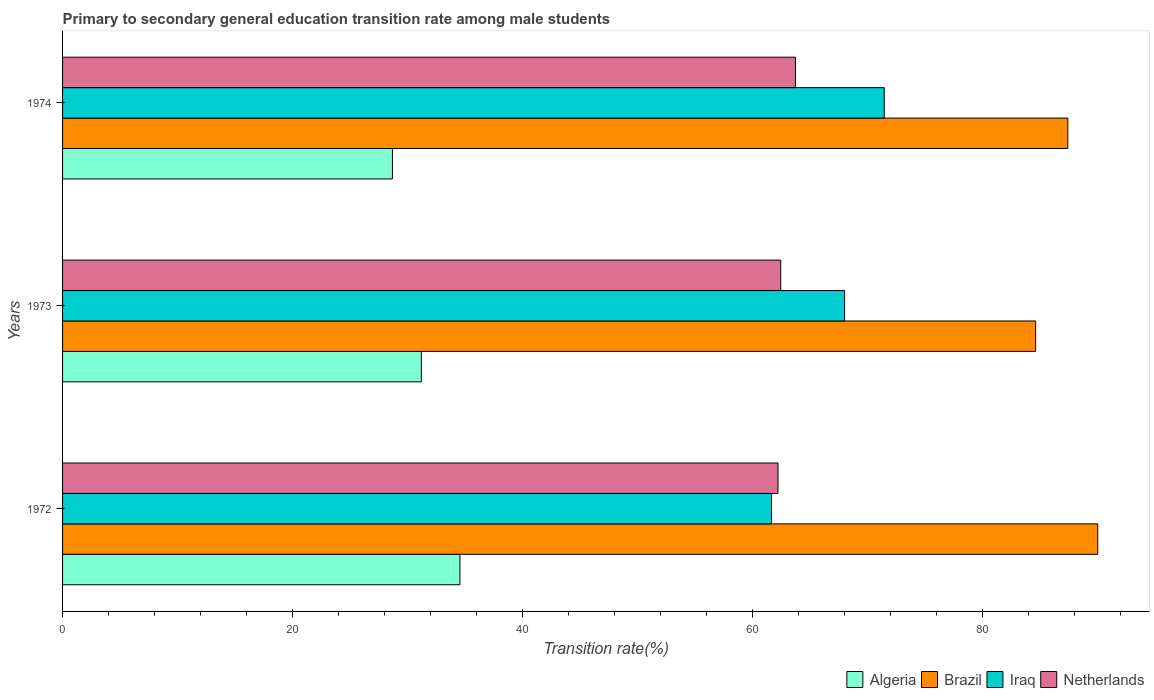How many different coloured bars are there?
Ensure brevity in your answer.  4. How many groups of bars are there?
Offer a very short reply. 3. Are the number of bars on each tick of the Y-axis equal?
Keep it short and to the point. Yes. How many bars are there on the 1st tick from the bottom?
Give a very brief answer. 4. What is the label of the 3rd group of bars from the top?
Give a very brief answer. 1972. What is the transition rate in Brazil in 1974?
Offer a terse response. 87.41. Across all years, what is the maximum transition rate in Netherlands?
Keep it short and to the point. 63.72. Across all years, what is the minimum transition rate in Algeria?
Keep it short and to the point. 28.68. What is the total transition rate in Netherlands in the graph?
Provide a short and direct response. 188.38. What is the difference between the transition rate in Iraq in 1973 and that in 1974?
Give a very brief answer. -3.45. What is the difference between the transition rate in Iraq in 1974 and the transition rate in Netherlands in 1972?
Provide a short and direct response. 9.24. What is the average transition rate in Iraq per year?
Your answer should be compact. 67.03. In the year 1973, what is the difference between the transition rate in Netherlands and transition rate in Algeria?
Provide a short and direct response. 31.26. What is the ratio of the transition rate in Iraq in 1972 to that in 1973?
Ensure brevity in your answer.  0.91. Is the transition rate in Algeria in 1972 less than that in 1974?
Your response must be concise. No. Is the difference between the transition rate in Netherlands in 1972 and 1974 greater than the difference between the transition rate in Algeria in 1972 and 1974?
Your answer should be compact. No. What is the difference between the highest and the second highest transition rate in Algeria?
Provide a short and direct response. 3.36. What is the difference between the highest and the lowest transition rate in Iraq?
Offer a very short reply. 9.8. In how many years, is the transition rate in Algeria greater than the average transition rate in Algeria taken over all years?
Offer a very short reply. 1. Is it the case that in every year, the sum of the transition rate in Brazil and transition rate in Algeria is greater than the sum of transition rate in Netherlands and transition rate in Iraq?
Your answer should be very brief. Yes. What does the 2nd bar from the top in 1974 represents?
Provide a succinct answer. Iraq. Is it the case that in every year, the sum of the transition rate in Algeria and transition rate in Iraq is greater than the transition rate in Brazil?
Keep it short and to the point. Yes. How many bars are there?
Offer a terse response. 12. How many years are there in the graph?
Offer a very short reply. 3. What is the difference between two consecutive major ticks on the X-axis?
Your answer should be compact. 20. Are the values on the major ticks of X-axis written in scientific E-notation?
Provide a short and direct response. No. Does the graph contain grids?
Offer a terse response. No. How are the legend labels stacked?
Your answer should be very brief. Horizontal. What is the title of the graph?
Provide a succinct answer. Primary to secondary general education transition rate among male students. Does "Georgia" appear as one of the legend labels in the graph?
Offer a very short reply. No. What is the label or title of the X-axis?
Your response must be concise. Transition rate(%). What is the label or title of the Y-axis?
Your answer should be compact. Years. What is the Transition rate(%) in Algeria in 1972?
Your response must be concise. 34.55. What is the Transition rate(%) in Brazil in 1972?
Offer a very short reply. 90.01. What is the Transition rate(%) in Iraq in 1972?
Give a very brief answer. 61.64. What is the Transition rate(%) of Netherlands in 1972?
Offer a very short reply. 62.21. What is the Transition rate(%) in Algeria in 1973?
Make the answer very short. 31.19. What is the Transition rate(%) of Brazil in 1973?
Your answer should be compact. 84.61. What is the Transition rate(%) in Iraq in 1973?
Your answer should be compact. 68. What is the Transition rate(%) of Netherlands in 1973?
Provide a succinct answer. 62.45. What is the Transition rate(%) of Algeria in 1974?
Provide a succinct answer. 28.68. What is the Transition rate(%) in Brazil in 1974?
Give a very brief answer. 87.41. What is the Transition rate(%) of Iraq in 1974?
Provide a short and direct response. 71.45. What is the Transition rate(%) of Netherlands in 1974?
Keep it short and to the point. 63.72. Across all years, what is the maximum Transition rate(%) of Algeria?
Keep it short and to the point. 34.55. Across all years, what is the maximum Transition rate(%) in Brazil?
Keep it short and to the point. 90.01. Across all years, what is the maximum Transition rate(%) in Iraq?
Give a very brief answer. 71.45. Across all years, what is the maximum Transition rate(%) in Netherlands?
Offer a terse response. 63.72. Across all years, what is the minimum Transition rate(%) of Algeria?
Ensure brevity in your answer.  28.68. Across all years, what is the minimum Transition rate(%) in Brazil?
Provide a succinct answer. 84.61. Across all years, what is the minimum Transition rate(%) in Iraq?
Ensure brevity in your answer.  61.64. Across all years, what is the minimum Transition rate(%) of Netherlands?
Keep it short and to the point. 62.21. What is the total Transition rate(%) in Algeria in the graph?
Keep it short and to the point. 94.43. What is the total Transition rate(%) of Brazil in the graph?
Provide a succinct answer. 262.03. What is the total Transition rate(%) of Iraq in the graph?
Provide a short and direct response. 201.09. What is the total Transition rate(%) of Netherlands in the graph?
Offer a very short reply. 188.38. What is the difference between the Transition rate(%) in Algeria in 1972 and that in 1973?
Your answer should be compact. 3.36. What is the difference between the Transition rate(%) in Brazil in 1972 and that in 1973?
Make the answer very short. 5.4. What is the difference between the Transition rate(%) in Iraq in 1972 and that in 1973?
Provide a short and direct response. -6.36. What is the difference between the Transition rate(%) in Netherlands in 1972 and that in 1973?
Ensure brevity in your answer.  -0.24. What is the difference between the Transition rate(%) of Algeria in 1972 and that in 1974?
Offer a terse response. 5.87. What is the difference between the Transition rate(%) in Brazil in 1972 and that in 1974?
Your answer should be compact. 2.6. What is the difference between the Transition rate(%) in Iraq in 1972 and that in 1974?
Provide a short and direct response. -9.8. What is the difference between the Transition rate(%) of Netherlands in 1972 and that in 1974?
Your response must be concise. -1.52. What is the difference between the Transition rate(%) in Algeria in 1973 and that in 1974?
Give a very brief answer. 2.51. What is the difference between the Transition rate(%) in Brazil in 1973 and that in 1974?
Your answer should be very brief. -2.8. What is the difference between the Transition rate(%) in Iraq in 1973 and that in 1974?
Your answer should be compact. -3.45. What is the difference between the Transition rate(%) in Netherlands in 1973 and that in 1974?
Keep it short and to the point. -1.28. What is the difference between the Transition rate(%) in Algeria in 1972 and the Transition rate(%) in Brazil in 1973?
Offer a terse response. -50.06. What is the difference between the Transition rate(%) of Algeria in 1972 and the Transition rate(%) of Iraq in 1973?
Keep it short and to the point. -33.45. What is the difference between the Transition rate(%) in Algeria in 1972 and the Transition rate(%) in Netherlands in 1973?
Ensure brevity in your answer.  -27.9. What is the difference between the Transition rate(%) of Brazil in 1972 and the Transition rate(%) of Iraq in 1973?
Provide a succinct answer. 22.01. What is the difference between the Transition rate(%) in Brazil in 1972 and the Transition rate(%) in Netherlands in 1973?
Provide a succinct answer. 27.56. What is the difference between the Transition rate(%) of Iraq in 1972 and the Transition rate(%) of Netherlands in 1973?
Ensure brevity in your answer.  -0.81. What is the difference between the Transition rate(%) in Algeria in 1972 and the Transition rate(%) in Brazil in 1974?
Provide a short and direct response. -52.86. What is the difference between the Transition rate(%) of Algeria in 1972 and the Transition rate(%) of Iraq in 1974?
Offer a very short reply. -36.89. What is the difference between the Transition rate(%) in Algeria in 1972 and the Transition rate(%) in Netherlands in 1974?
Give a very brief answer. -29.17. What is the difference between the Transition rate(%) in Brazil in 1972 and the Transition rate(%) in Iraq in 1974?
Your answer should be very brief. 18.56. What is the difference between the Transition rate(%) of Brazil in 1972 and the Transition rate(%) of Netherlands in 1974?
Keep it short and to the point. 26.29. What is the difference between the Transition rate(%) of Iraq in 1972 and the Transition rate(%) of Netherlands in 1974?
Your answer should be compact. -2.08. What is the difference between the Transition rate(%) in Algeria in 1973 and the Transition rate(%) in Brazil in 1974?
Provide a short and direct response. -56.22. What is the difference between the Transition rate(%) in Algeria in 1973 and the Transition rate(%) in Iraq in 1974?
Your response must be concise. -40.25. What is the difference between the Transition rate(%) in Algeria in 1973 and the Transition rate(%) in Netherlands in 1974?
Provide a succinct answer. -32.53. What is the difference between the Transition rate(%) in Brazil in 1973 and the Transition rate(%) in Iraq in 1974?
Ensure brevity in your answer.  13.16. What is the difference between the Transition rate(%) of Brazil in 1973 and the Transition rate(%) of Netherlands in 1974?
Ensure brevity in your answer.  20.89. What is the difference between the Transition rate(%) of Iraq in 1973 and the Transition rate(%) of Netherlands in 1974?
Give a very brief answer. 4.27. What is the average Transition rate(%) in Algeria per year?
Provide a short and direct response. 31.48. What is the average Transition rate(%) in Brazil per year?
Make the answer very short. 87.34. What is the average Transition rate(%) of Iraq per year?
Offer a very short reply. 67.03. What is the average Transition rate(%) of Netherlands per year?
Provide a short and direct response. 62.79. In the year 1972, what is the difference between the Transition rate(%) of Algeria and Transition rate(%) of Brazil?
Offer a terse response. -55.46. In the year 1972, what is the difference between the Transition rate(%) of Algeria and Transition rate(%) of Iraq?
Offer a very short reply. -27.09. In the year 1972, what is the difference between the Transition rate(%) in Algeria and Transition rate(%) in Netherlands?
Provide a short and direct response. -27.65. In the year 1972, what is the difference between the Transition rate(%) in Brazil and Transition rate(%) in Iraq?
Keep it short and to the point. 28.37. In the year 1972, what is the difference between the Transition rate(%) of Brazil and Transition rate(%) of Netherlands?
Your answer should be very brief. 27.8. In the year 1972, what is the difference between the Transition rate(%) in Iraq and Transition rate(%) in Netherlands?
Ensure brevity in your answer.  -0.57. In the year 1973, what is the difference between the Transition rate(%) in Algeria and Transition rate(%) in Brazil?
Provide a succinct answer. -53.42. In the year 1973, what is the difference between the Transition rate(%) in Algeria and Transition rate(%) in Iraq?
Provide a short and direct response. -36.81. In the year 1973, what is the difference between the Transition rate(%) of Algeria and Transition rate(%) of Netherlands?
Offer a very short reply. -31.26. In the year 1973, what is the difference between the Transition rate(%) in Brazil and Transition rate(%) in Iraq?
Give a very brief answer. 16.61. In the year 1973, what is the difference between the Transition rate(%) in Brazil and Transition rate(%) in Netherlands?
Give a very brief answer. 22.16. In the year 1973, what is the difference between the Transition rate(%) of Iraq and Transition rate(%) of Netherlands?
Offer a very short reply. 5.55. In the year 1974, what is the difference between the Transition rate(%) of Algeria and Transition rate(%) of Brazil?
Make the answer very short. -58.73. In the year 1974, what is the difference between the Transition rate(%) of Algeria and Transition rate(%) of Iraq?
Ensure brevity in your answer.  -42.76. In the year 1974, what is the difference between the Transition rate(%) of Algeria and Transition rate(%) of Netherlands?
Your answer should be very brief. -35.04. In the year 1974, what is the difference between the Transition rate(%) in Brazil and Transition rate(%) in Iraq?
Ensure brevity in your answer.  15.96. In the year 1974, what is the difference between the Transition rate(%) of Brazil and Transition rate(%) of Netherlands?
Make the answer very short. 23.69. In the year 1974, what is the difference between the Transition rate(%) of Iraq and Transition rate(%) of Netherlands?
Give a very brief answer. 7.72. What is the ratio of the Transition rate(%) of Algeria in 1972 to that in 1973?
Your response must be concise. 1.11. What is the ratio of the Transition rate(%) of Brazil in 1972 to that in 1973?
Provide a short and direct response. 1.06. What is the ratio of the Transition rate(%) in Iraq in 1972 to that in 1973?
Your response must be concise. 0.91. What is the ratio of the Transition rate(%) of Netherlands in 1972 to that in 1973?
Your answer should be very brief. 1. What is the ratio of the Transition rate(%) of Algeria in 1972 to that in 1974?
Make the answer very short. 1.2. What is the ratio of the Transition rate(%) in Brazil in 1972 to that in 1974?
Provide a succinct answer. 1.03. What is the ratio of the Transition rate(%) of Iraq in 1972 to that in 1974?
Give a very brief answer. 0.86. What is the ratio of the Transition rate(%) of Netherlands in 1972 to that in 1974?
Your response must be concise. 0.98. What is the ratio of the Transition rate(%) of Algeria in 1973 to that in 1974?
Make the answer very short. 1.09. What is the ratio of the Transition rate(%) of Brazil in 1973 to that in 1974?
Your response must be concise. 0.97. What is the ratio of the Transition rate(%) of Iraq in 1973 to that in 1974?
Ensure brevity in your answer.  0.95. What is the difference between the highest and the second highest Transition rate(%) in Algeria?
Your answer should be very brief. 3.36. What is the difference between the highest and the second highest Transition rate(%) of Brazil?
Make the answer very short. 2.6. What is the difference between the highest and the second highest Transition rate(%) of Iraq?
Offer a terse response. 3.45. What is the difference between the highest and the second highest Transition rate(%) in Netherlands?
Your answer should be very brief. 1.28. What is the difference between the highest and the lowest Transition rate(%) in Algeria?
Keep it short and to the point. 5.87. What is the difference between the highest and the lowest Transition rate(%) of Brazil?
Provide a short and direct response. 5.4. What is the difference between the highest and the lowest Transition rate(%) in Iraq?
Provide a short and direct response. 9.8. What is the difference between the highest and the lowest Transition rate(%) in Netherlands?
Ensure brevity in your answer.  1.52. 